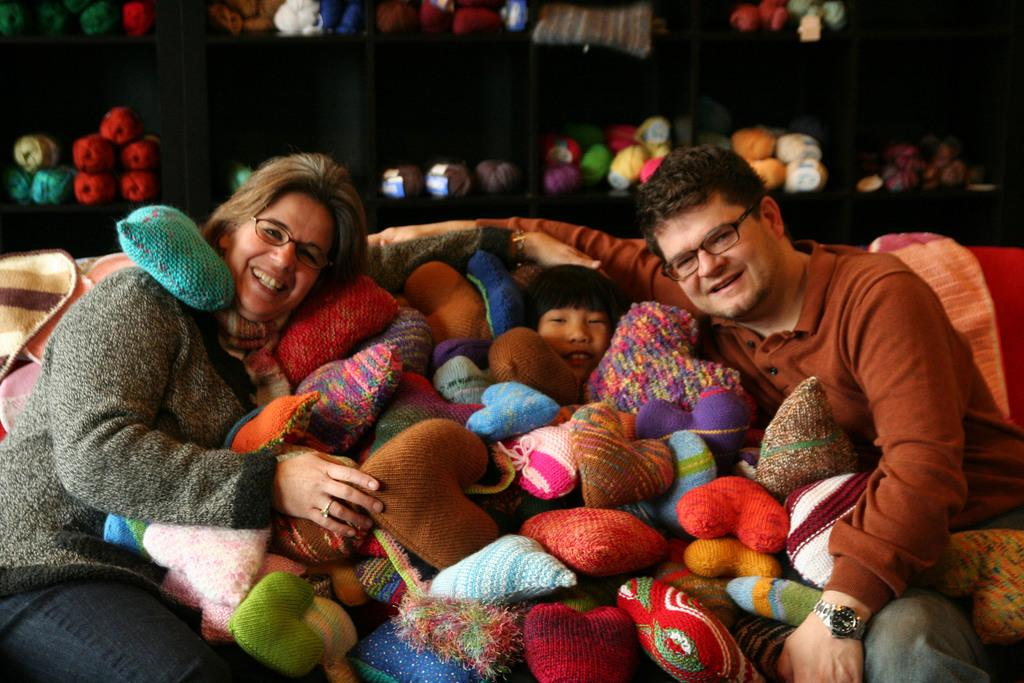How many people are sitting on the sofa in the image? There are three people sitting on the sofa in the image. What is above the middle person on the sofa? There are small pillows above the middle person. What can be seen behind the people on the sofa? There is a rack behind the people. What is stored on the rack? The rack is stored with woolen yarn. What book is the writer reading on the sofa? There is no writer or book present in the image; it only shows three people sitting on the sofa. 